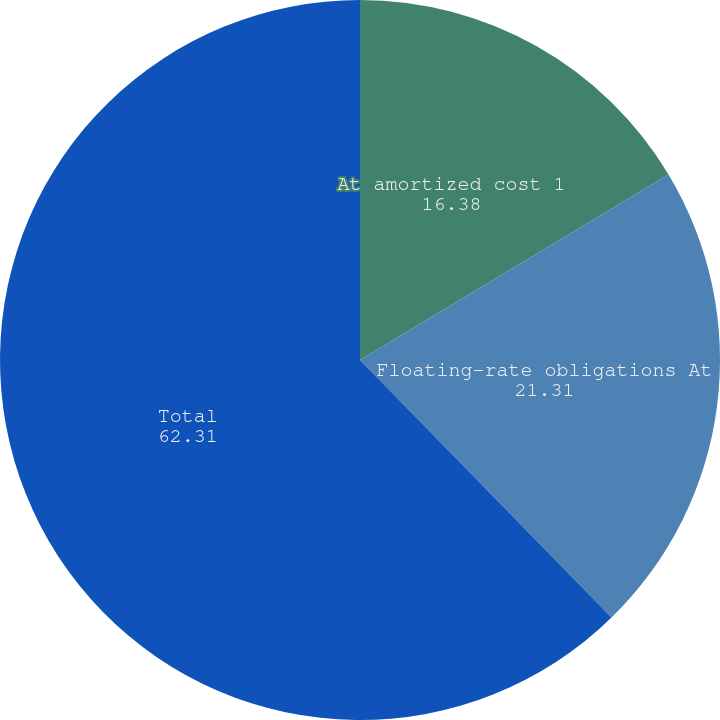<chart> <loc_0><loc_0><loc_500><loc_500><pie_chart><fcel>At amortized cost 1<fcel>Floating-rate obligations At<fcel>Total<nl><fcel>16.38%<fcel>21.31%<fcel>62.31%<nl></chart> 